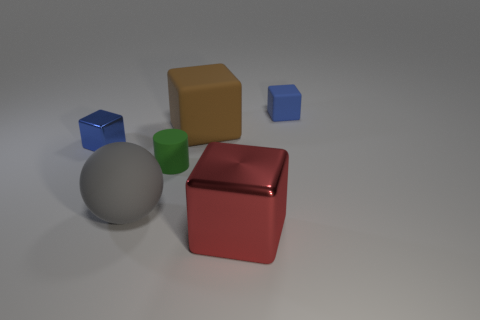Is there a tiny blue shiny cube to the right of the big block in front of the metal block to the left of the tiny green rubber thing? no 